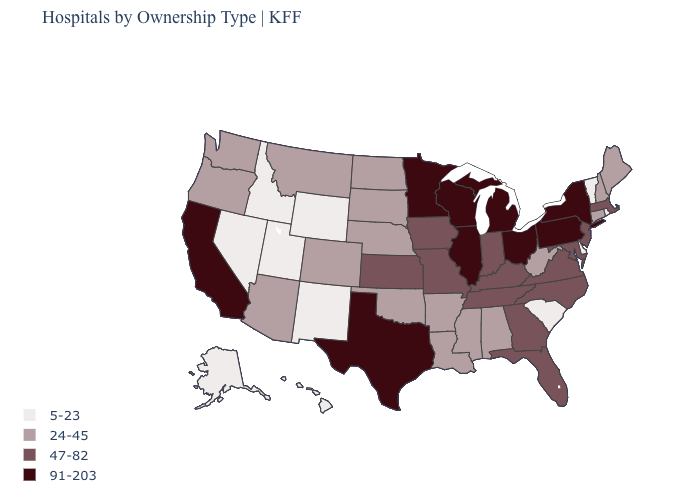What is the value of Missouri?
Short answer required. 47-82. What is the value of Georgia?
Keep it brief. 47-82. Does the map have missing data?
Write a very short answer. No. What is the value of Rhode Island?
Write a very short answer. 5-23. Name the states that have a value in the range 24-45?
Write a very short answer. Alabama, Arizona, Arkansas, Colorado, Connecticut, Louisiana, Maine, Mississippi, Montana, Nebraska, New Hampshire, North Dakota, Oklahoma, Oregon, South Dakota, Washington, West Virginia. What is the value of Maine?
Keep it brief. 24-45. Name the states that have a value in the range 24-45?
Quick response, please. Alabama, Arizona, Arkansas, Colorado, Connecticut, Louisiana, Maine, Mississippi, Montana, Nebraska, New Hampshire, North Dakota, Oklahoma, Oregon, South Dakota, Washington, West Virginia. What is the value of Oregon?
Answer briefly. 24-45. What is the lowest value in states that border New Mexico?
Concise answer only. 5-23. Does Illinois have a lower value than Oregon?
Quick response, please. No. Which states hav the highest value in the MidWest?
Answer briefly. Illinois, Michigan, Minnesota, Ohio, Wisconsin. Name the states that have a value in the range 5-23?
Quick response, please. Alaska, Delaware, Hawaii, Idaho, Nevada, New Mexico, Rhode Island, South Carolina, Utah, Vermont, Wyoming. What is the highest value in the MidWest ?
Short answer required. 91-203. Does Alaska have a lower value than South Carolina?
Concise answer only. No. Which states have the highest value in the USA?
Give a very brief answer. California, Illinois, Michigan, Minnesota, New York, Ohio, Pennsylvania, Texas, Wisconsin. 